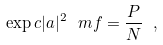Convert formula to latex. <formula><loc_0><loc_0><loc_500><loc_500>\exp c { | a | ^ { 2 } } _ { \ } m f = \frac { P } { N } \ ,</formula> 